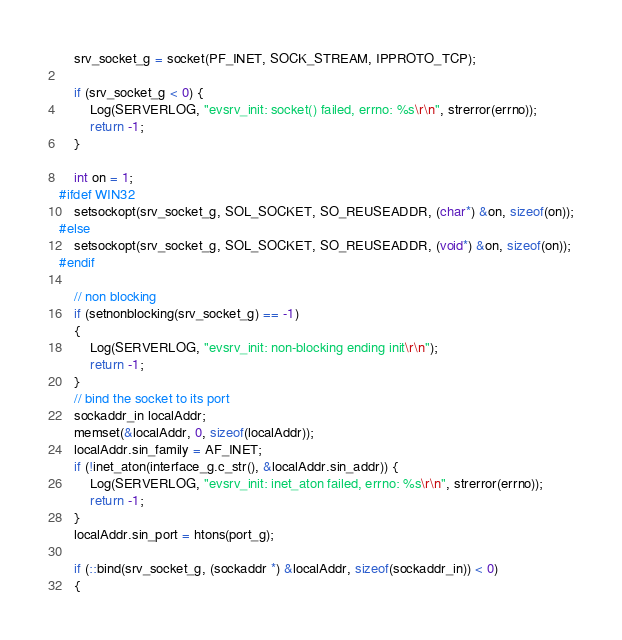Convert code to text. <code><loc_0><loc_0><loc_500><loc_500><_C++_>    srv_socket_g = socket(PF_INET, SOCK_STREAM, IPPROTO_TCP);
    
    if (srv_socket_g < 0) {
        Log(SERVERLOG, "evsrv_init: socket() failed, errno: %s\r\n", strerror(errno));
        return -1;
    }

	int on = 1;
#ifdef WIN32
	setsockopt(srv_socket_g, SOL_SOCKET, SO_REUSEADDR, (char*) &on, sizeof(on));
#else
	setsockopt(srv_socket_g, SOL_SOCKET, SO_REUSEADDR, (void*) &on, sizeof(on));
#endif
    
    // non blocking
    if (setnonblocking(srv_socket_g) == -1)  
	{
		Log(SERVERLOG, "evsrv_init: non-blocking ending init\r\n");
 		return -1;
	}
	// bind the socket to its port
	sockaddr_in localAddr;
	memset(&localAddr, 0, sizeof(localAddr));
	localAddr.sin_family = AF_INET;
    if (!inet_aton(interface_g.c_str(), &localAddr.sin_addr)) {
        Log(SERVERLOG, "evsrv_init: inet_aton failed, errno: %s\r\n", strerror(errno));
        return -1;
    }
	localAddr.sin_port = htons(port_g);
    
	if (::bind(srv_socket_g, (sockaddr *) &localAddr, sizeof(sockaddr_in)) < 0) 
	{</code> 